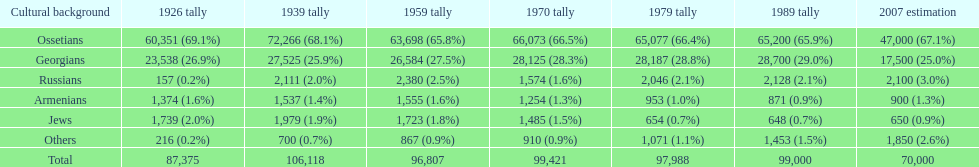How many ethnic groups are there? 6. 